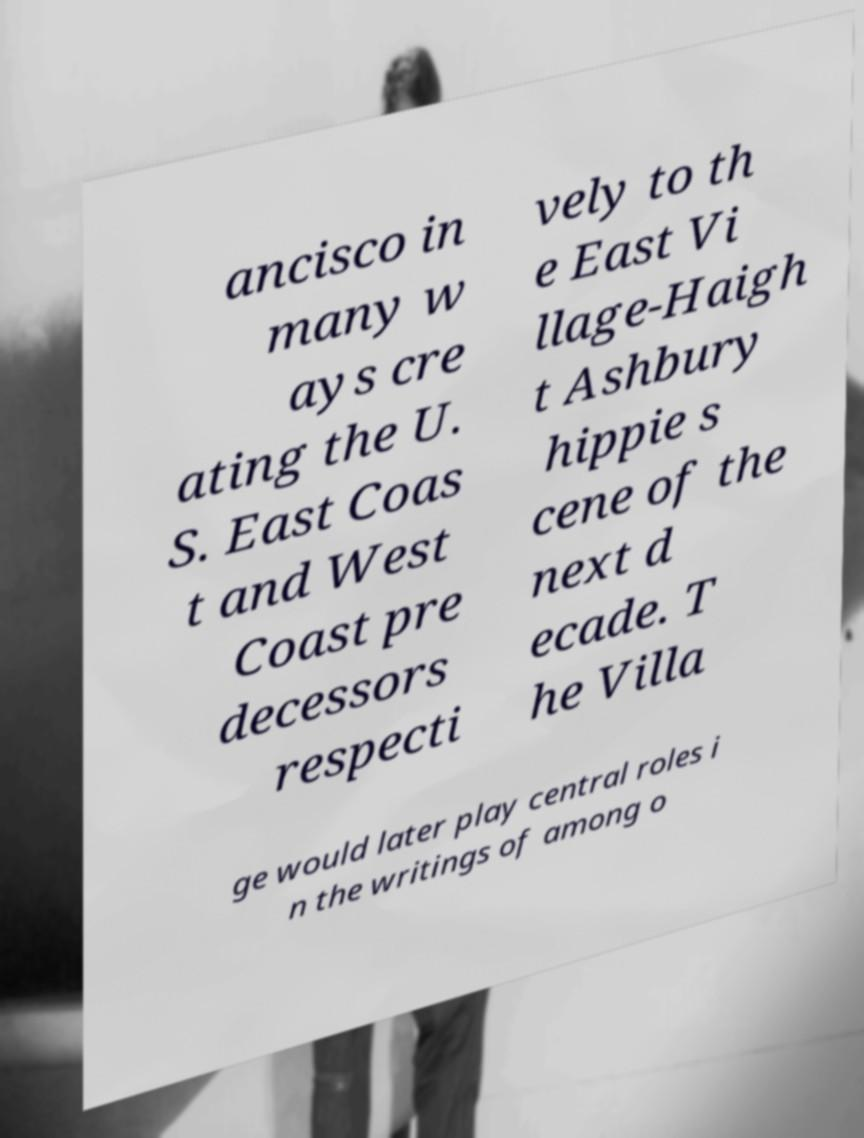Could you extract and type out the text from this image? ancisco in many w ays cre ating the U. S. East Coas t and West Coast pre decessors respecti vely to th e East Vi llage-Haigh t Ashbury hippie s cene of the next d ecade. T he Villa ge would later play central roles i n the writings of among o 